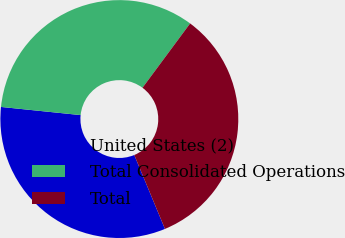Convert chart. <chart><loc_0><loc_0><loc_500><loc_500><pie_chart><fcel>United States (2)<fcel>Total Consolidated Operations<fcel>Total<nl><fcel>32.89%<fcel>33.52%<fcel>33.59%<nl></chart> 